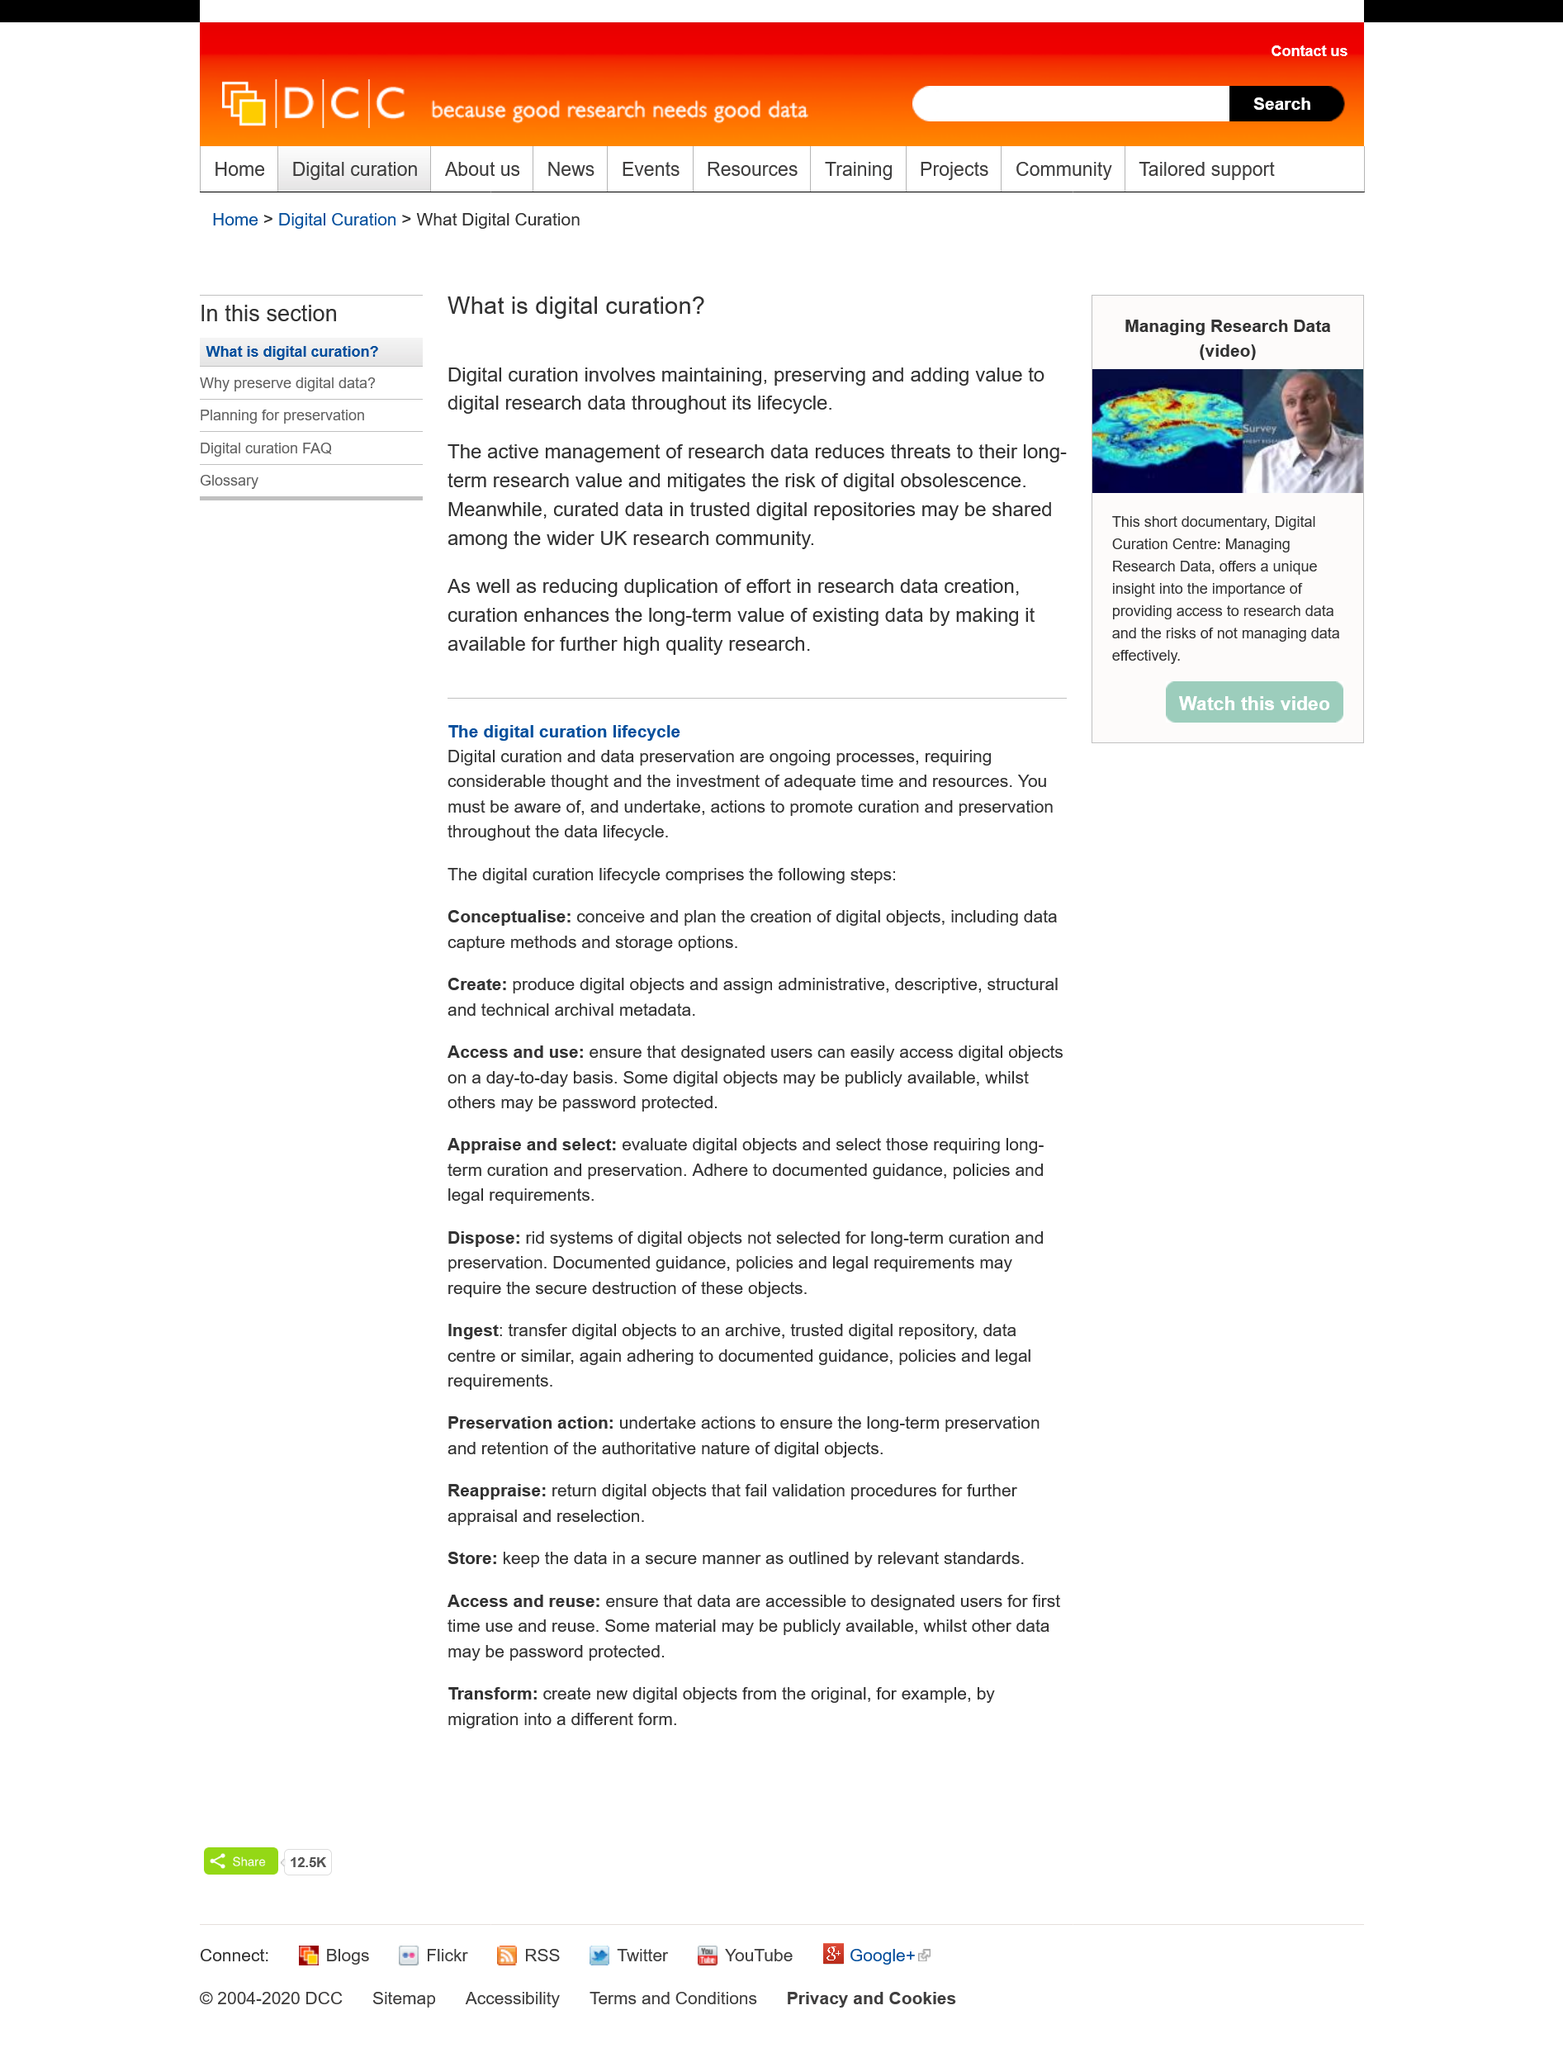Specify some key components in this picture. Digital curation involves maintaining, preserving, and adding value to digital research data. The title of this page is "what is digital curation. Digital curation does add value to digital research. 